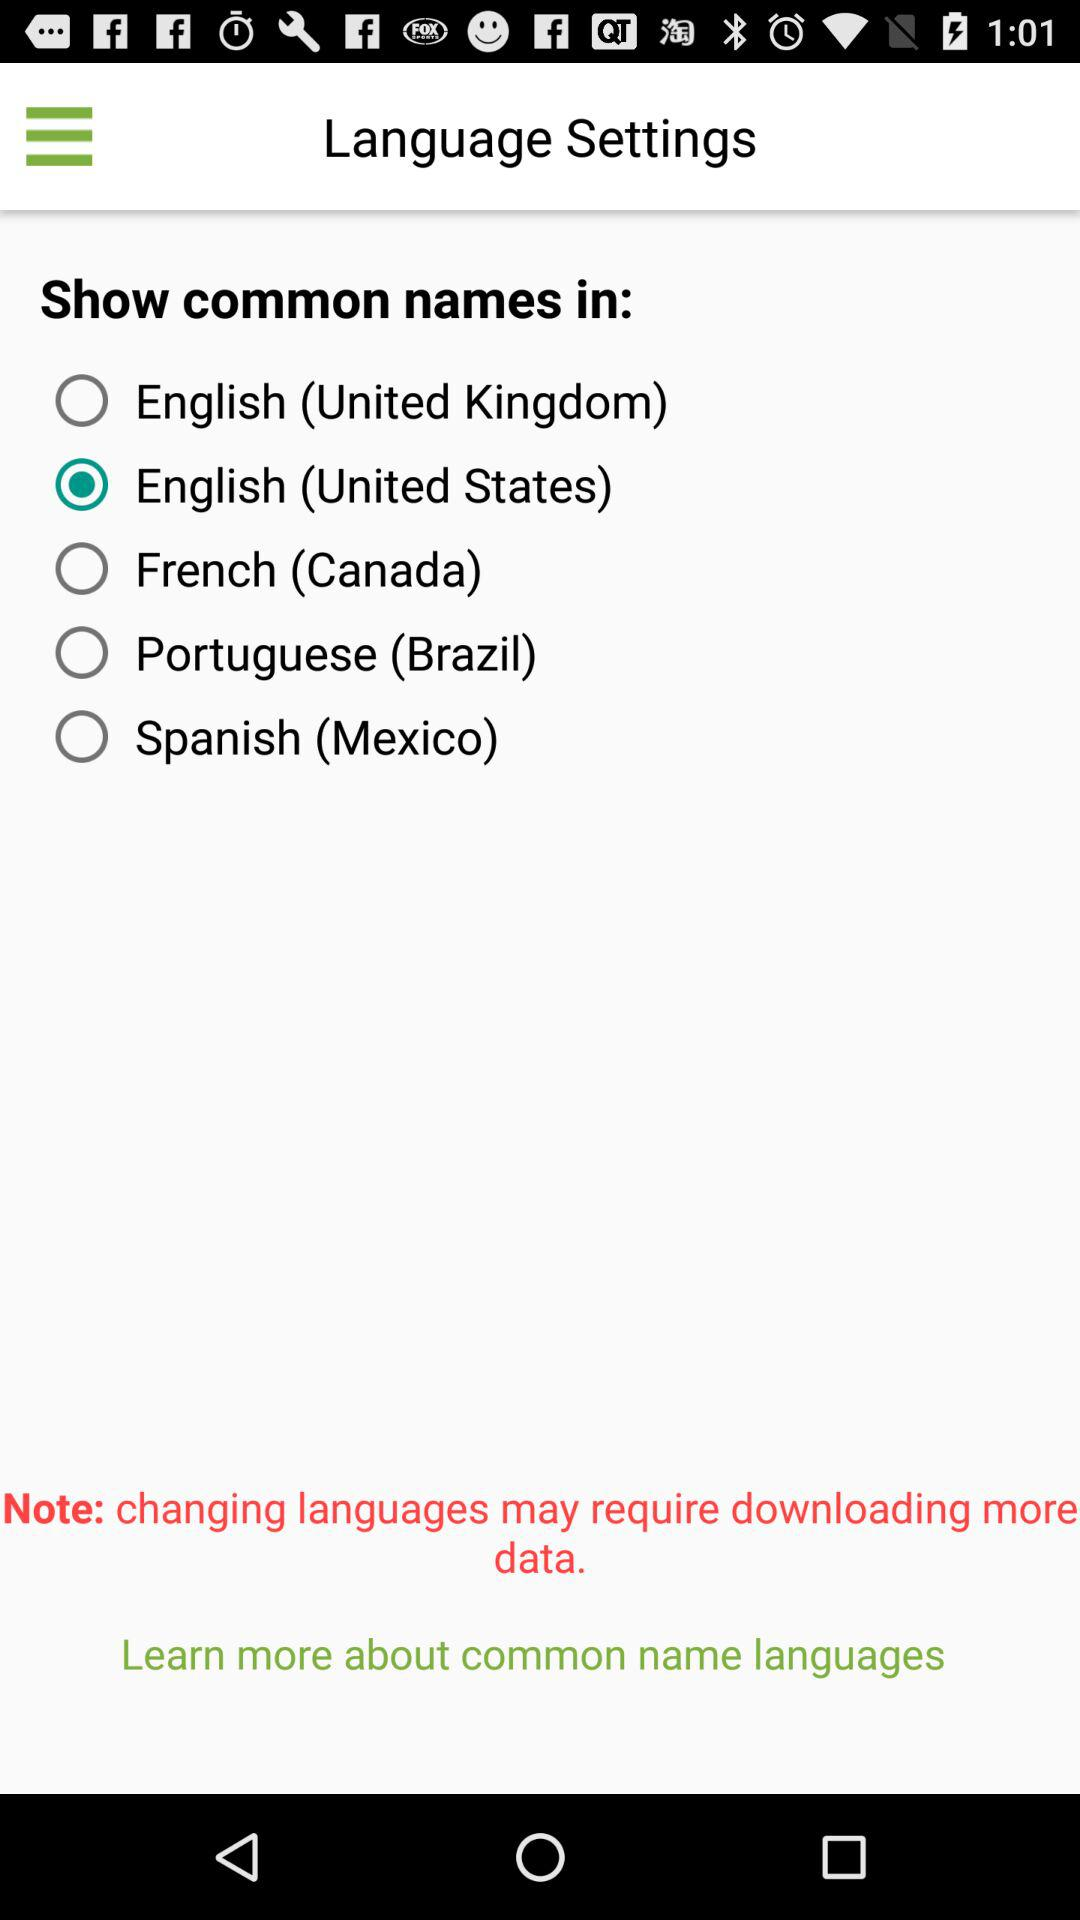How many languages are available to show common names in?
Answer the question using a single word or phrase. 5 